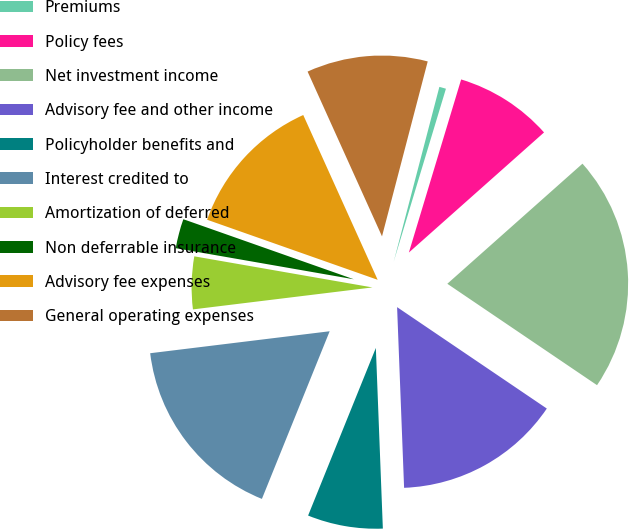Convert chart to OTSL. <chart><loc_0><loc_0><loc_500><loc_500><pie_chart><fcel>Premiums<fcel>Policy fees<fcel>Net investment income<fcel>Advisory fee and other income<fcel>Policyholder benefits and<fcel>Interest credited to<fcel>Amortization of deferred<fcel>Non deferrable insurance<fcel>Advisory fee expenses<fcel>General operating expenses<nl><fcel>0.6%<fcel>8.77%<fcel>21.04%<fcel>14.91%<fcel>6.73%<fcel>16.95%<fcel>4.69%<fcel>2.64%<fcel>12.86%<fcel>10.82%<nl></chart> 